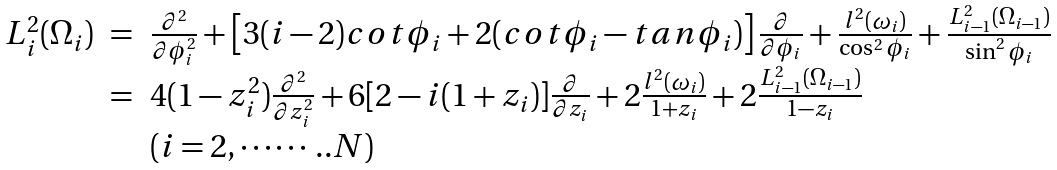Convert formula to latex. <formula><loc_0><loc_0><loc_500><loc_500>\begin{array} { r c l } L _ { i } ^ { 2 } ( \Omega _ { i } ) & = & \frac { \partial ^ { 2 } } { \partial \phi _ { i } ^ { 2 } } + \left [ 3 ( i - 2 ) c o t \phi _ { i } + 2 ( c o t \phi _ { i } - t a n \phi _ { i } ) \right ] \frac { \partial } { \partial \phi _ { i } } + \frac { l ^ { 2 } ( \omega _ { i } ) } { \cos ^ { 2 } \phi _ { i } } + \frac { L ^ { 2 } _ { i - 1 } ( \Omega _ { i - 1 } ) } { \sin ^ { 2 } \phi _ { i } } \\ & = & 4 ( 1 - z _ { i } ^ { 2 } ) \frac { \partial ^ { 2 } } { \partial z _ { i } ^ { 2 } } + 6 [ 2 - i ( 1 + z _ { i } ) ] \frac { \partial } { \partial z _ { i } } + 2 \frac { l ^ { 2 } ( \omega _ { i } ) } { 1 + z _ { i } } + 2 \frac { L ^ { 2 } _ { i - 1 } ( \Omega _ { i - 1 } ) } { 1 - z _ { i } } \\ & & ( i = 2 , \cdots \cdots . . N ) \end{array}</formula> 